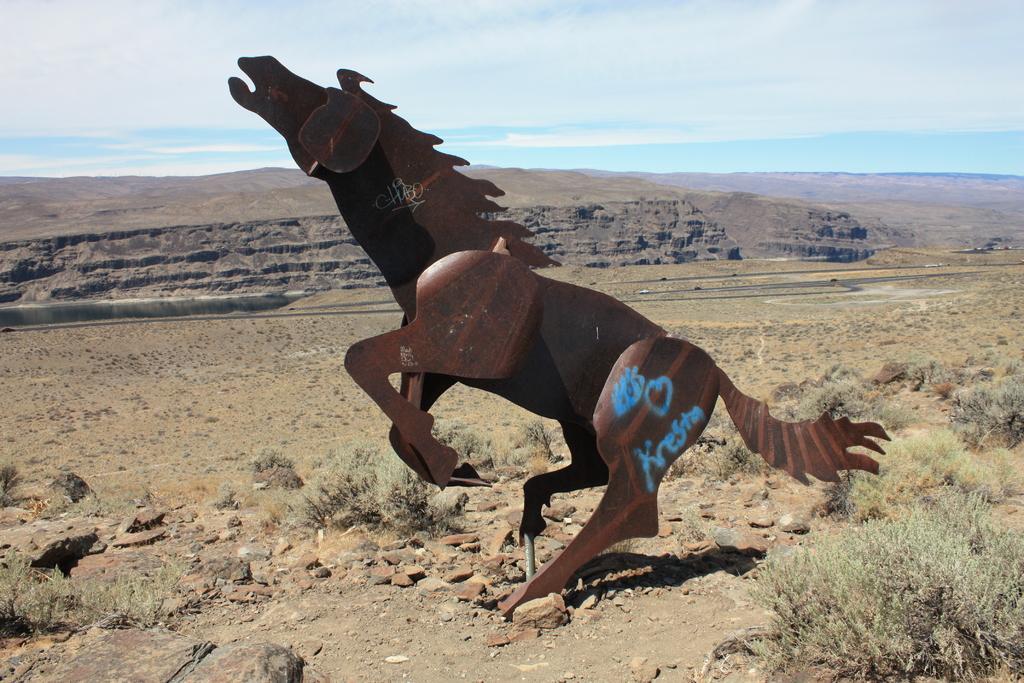Can you describe this image briefly? In this image, at the middle we can see a horse statue, there are some stones on the ground, at the top there is a sky which is cloudy. 